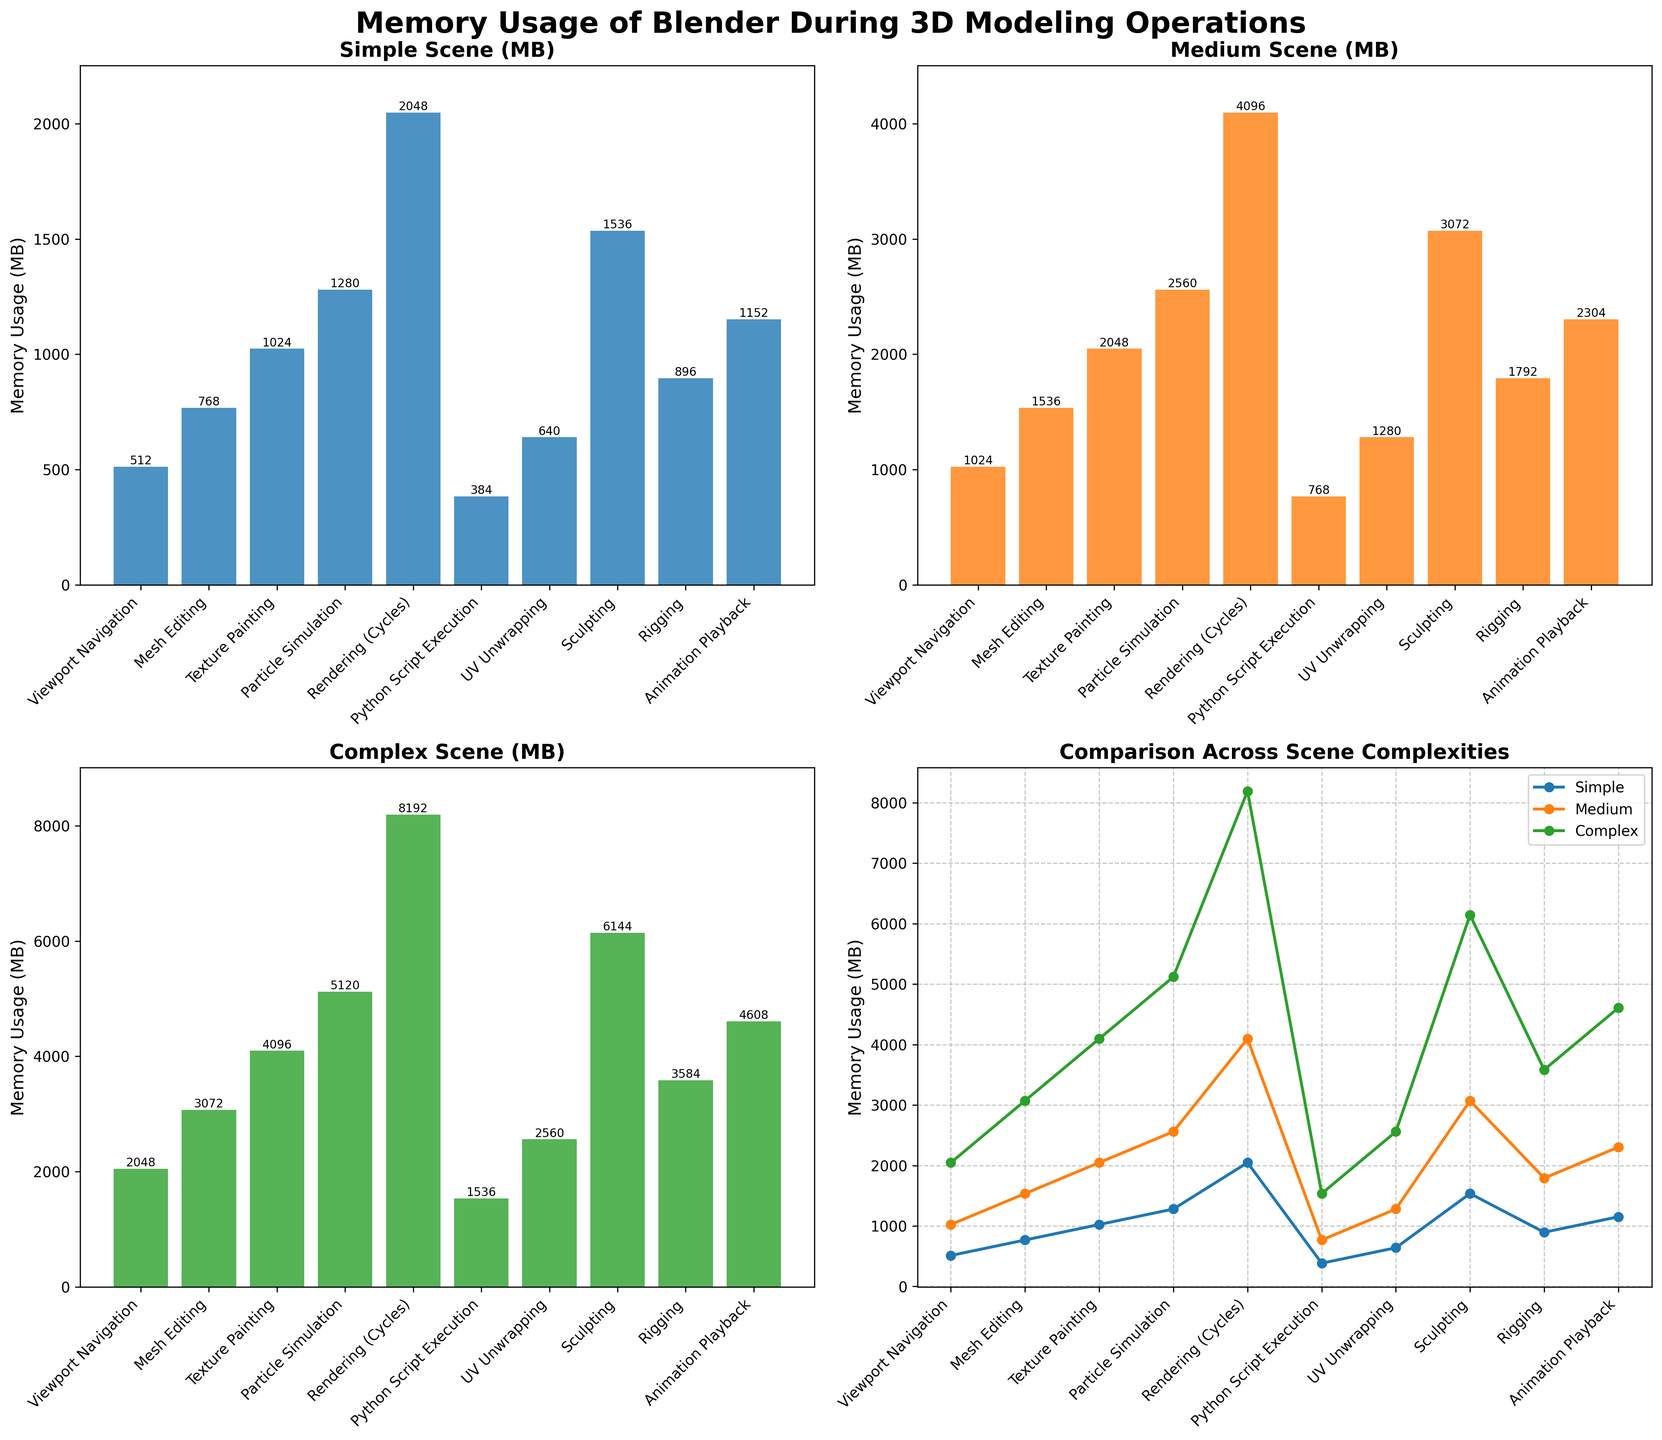What are the three types of scene complexities mentioned in the figure? The figure titles each subplot based on scene complexities. They are "Simple Scene (MB)", "Medium Scene (MB)", and "Complex Scene (MB)".
Answer: Simple Scene, Medium Scene, Complex Scene Which operation has the highest memory usage in a simple scene? In the bar plot titled "Simple Scene (MB)", the operation with the tallest bar is "Rendering (Cycles)" which has 2048 MB.
Answer: Rendering (Cycles) How much more memory does Sculpting use compared to Rigging in a complex scene? From the "Complex Scene (MB)" bar chart, Sculpting uses 6144 MB and Rigging uses 3584 MB. The difference is 6144 - 3584 = 2560 MB.
Answer: 2560 MB Which scene type shows the most significant difference in memory usage between Viewport Navigation and Animation Playback? Comparing the heights of the bars for Viewport Navigation and Animation Playback in each subplot, the difference is most significant in the "Complex Scene (MB)" subplot where Viewport Navigation uses 2048 MB and Animation Playback uses 4608 MB. The difference is 2560 MB.
Answer: Complex Scene Which operation consistently increases memory usage as scene complexity increases? Looking at the line plot, the operation that consistently shows an increase in memory usage across Simple, Medium, and Complex scenes is "Rendering (Cycles)".
Answer: Rendering (Cycles) On average, how much memory does Particle Simulation use across all scene complexities? Particle Simulation memory usage values are 1280 MB, 2560 MB, and 5120 MB for Simple, Medium, and Complex scenes respectively. The average is (1280 + 2560 + 5120) / 3 = 2987 MB.
Answer: 2987 MB Is the memory usage for Texture Painting greater than Mesh Editing for all scene complexities? Reviewing all three bar charts for Texture Painting and Mesh Editing, Texture Painting always has higher memory usage (1024 MB vs. 768 MB, 2048 MB vs. 1536 MB, 4096 MB vs. 3072 MB).
Answer: Yes In which scene is the memory usage for Python Script Execution the lowest? Python Script Execution bar is the smallest in the "Simple Scene (MB)" bar plot with 384 MB.
Answer: Simple Scene 